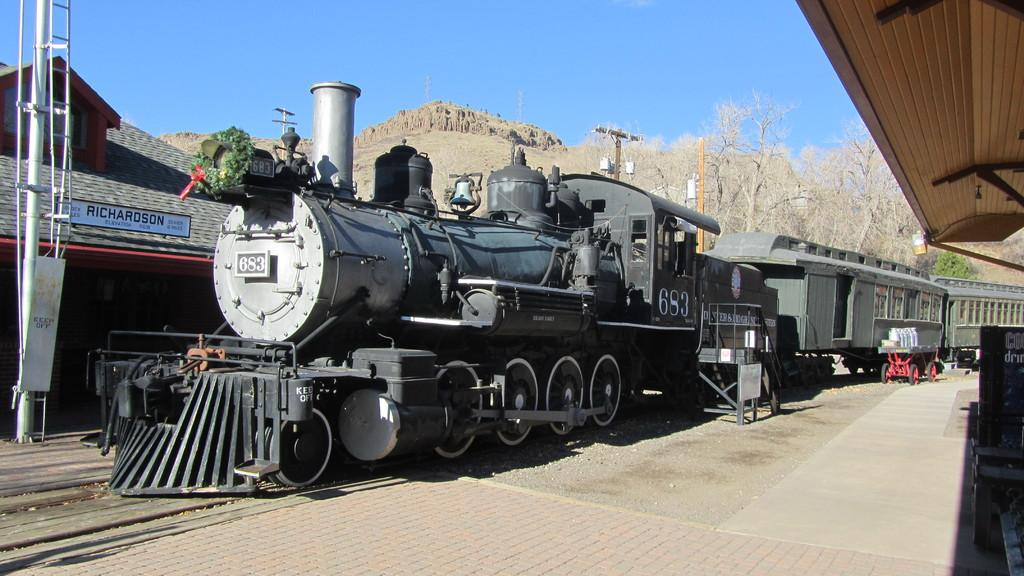What is the main subject of the image? There is a train in the image. Can you describe the train's position in the image? The train is on a track. What can be seen in the background of the image? There are trees and a mountain in the background of the image. What type of mind can be seen in the image? There is no mind present in the image; it features a train on a track with trees and a mountain in the background. 